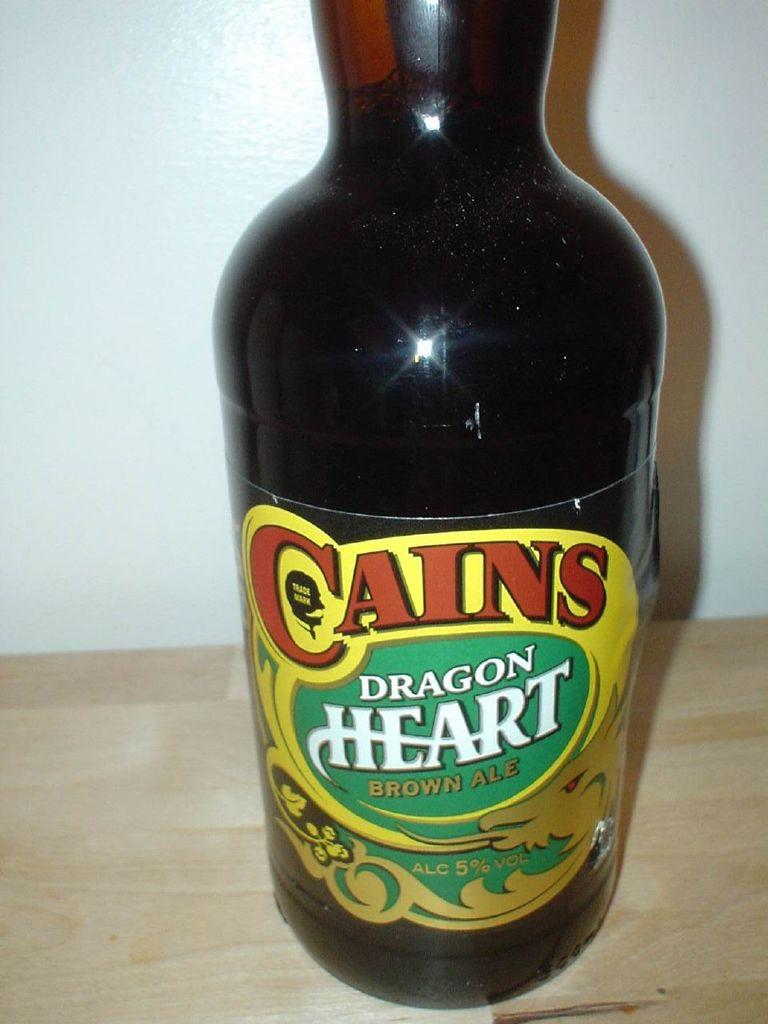<image>
Create a compact narrative representing the image presented. Cains Dragon Heart is a brown ale containing 5% alcohol. 